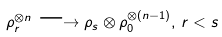<formula> <loc_0><loc_0><loc_500><loc_500>\rho _ { r } ^ { \otimes n } \longrightarrow \rho _ { s } \otimes \rho _ { 0 } ^ { \otimes ( n - 1 ) } , \, r < s</formula> 